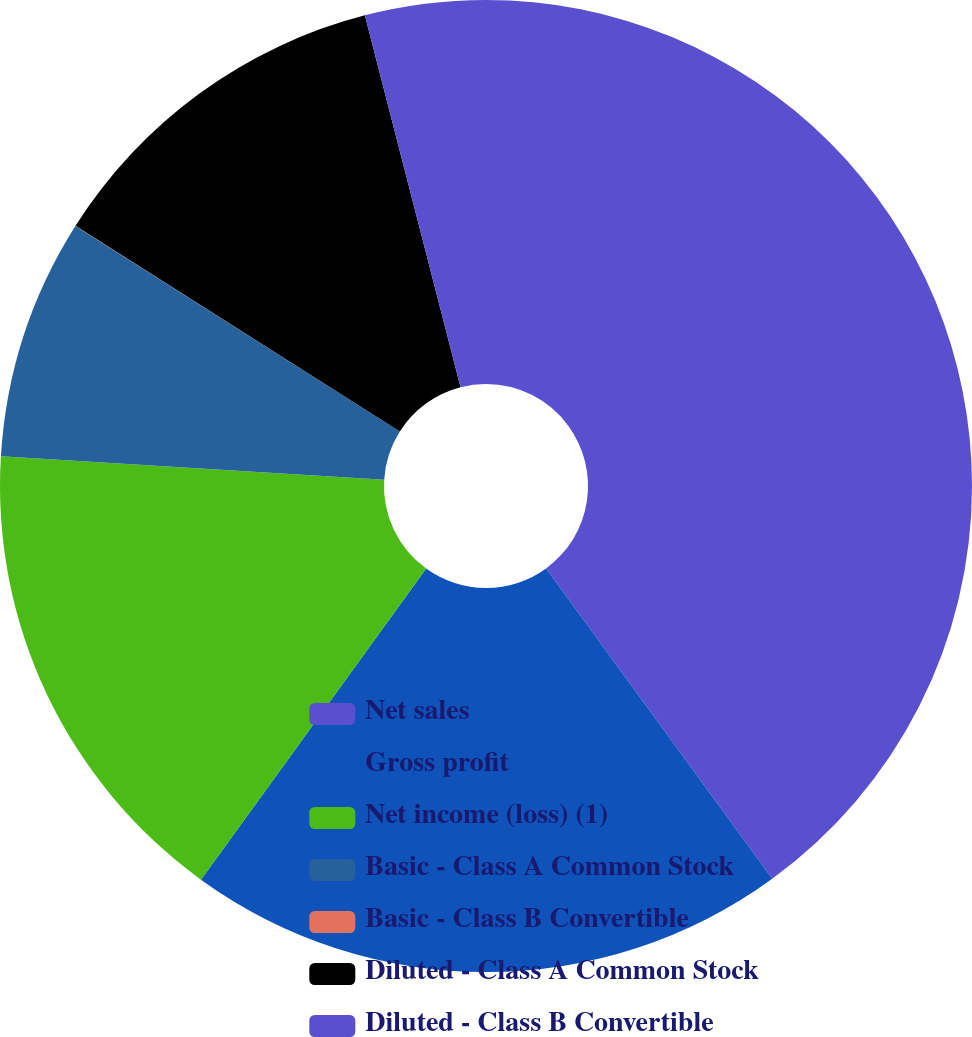<chart> <loc_0><loc_0><loc_500><loc_500><pie_chart><fcel>Net sales<fcel>Gross profit<fcel>Net income (loss) (1)<fcel>Basic - Class A Common Stock<fcel>Basic - Class B Convertible<fcel>Diluted - Class A Common Stock<fcel>Diluted - Class B Convertible<nl><fcel>39.98%<fcel>20.0%<fcel>16.0%<fcel>8.01%<fcel>0.01%<fcel>12.0%<fcel>4.01%<nl></chart> 